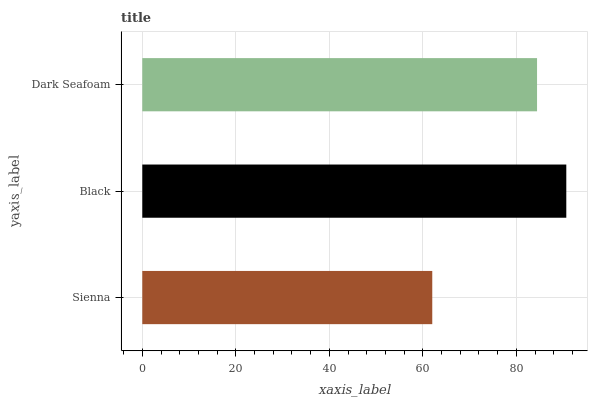Is Sienna the minimum?
Answer yes or no. Yes. Is Black the maximum?
Answer yes or no. Yes. Is Dark Seafoam the minimum?
Answer yes or no. No. Is Dark Seafoam the maximum?
Answer yes or no. No. Is Black greater than Dark Seafoam?
Answer yes or no. Yes. Is Dark Seafoam less than Black?
Answer yes or no. Yes. Is Dark Seafoam greater than Black?
Answer yes or no. No. Is Black less than Dark Seafoam?
Answer yes or no. No. Is Dark Seafoam the high median?
Answer yes or no. Yes. Is Dark Seafoam the low median?
Answer yes or no. Yes. Is Sienna the high median?
Answer yes or no. No. Is Sienna the low median?
Answer yes or no. No. 